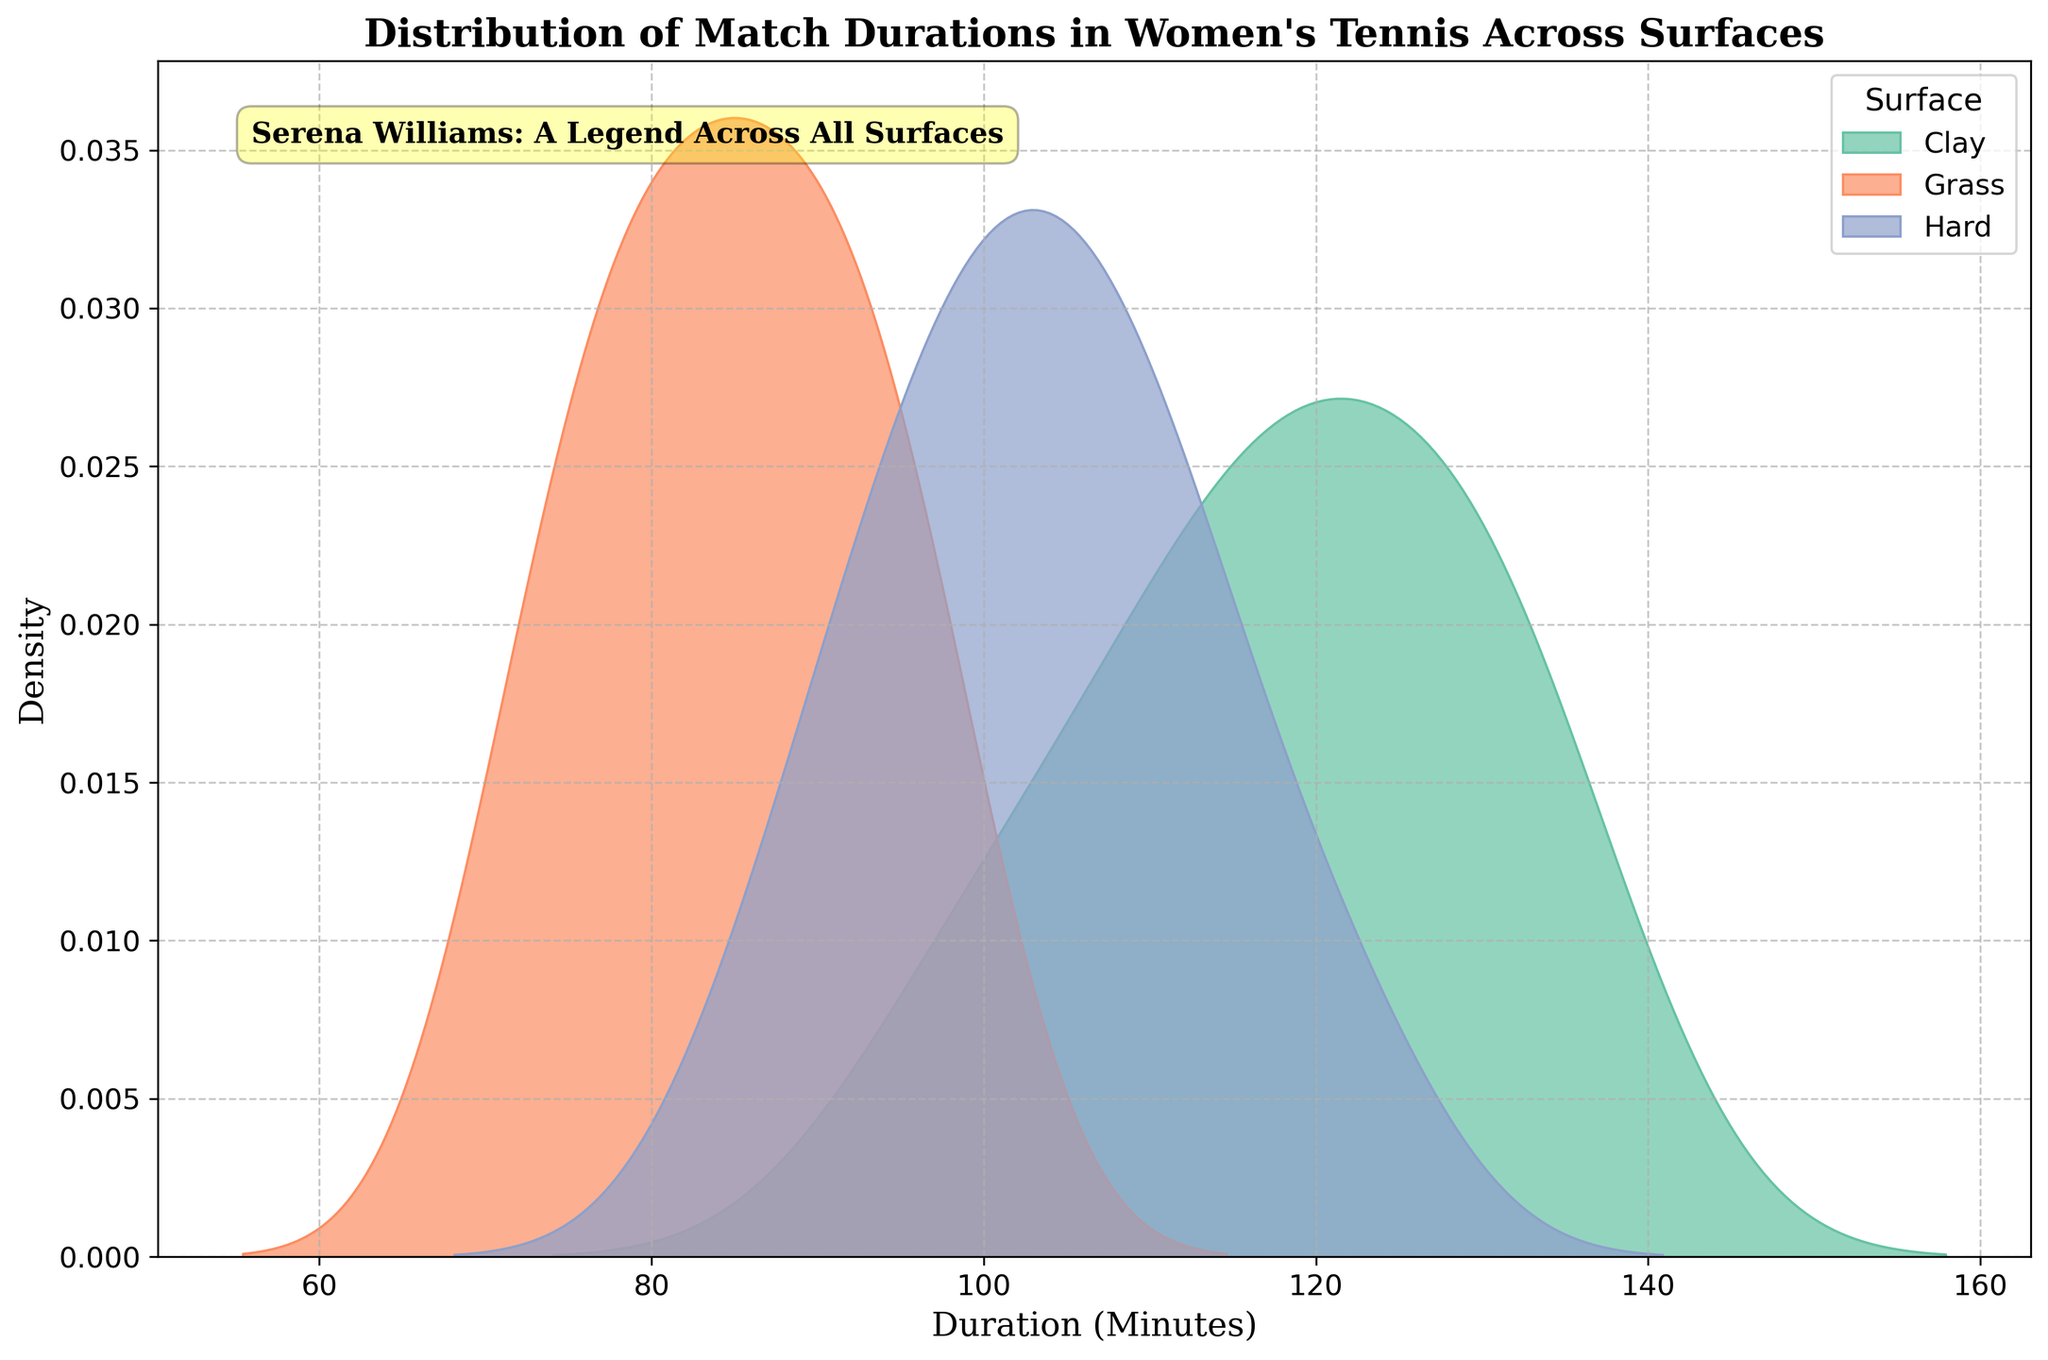What is the title of the figure? The title of the figure is usually placed at the top of the plot. In this case, it reads "Distribution of Match Durations in Women's Tennis Across Surfaces".
Answer: Distribution of Match Durations in Women's Tennis Across Surfaces Which surface has the highest peak in the density plot? To find this, examine the peaks of the different surface curves. The surface with the highest peak in density is the one with the tallest curve.
Answer: Clay What are the axes labels? The axes labels are shown along the x-axis and y-axis of the plot. The x-axis is labeled "Duration (Minutes)" and the y-axis is labeled "Density".
Answer: Duration (Minutes) for x-axis and Density for y-axis Which surface has the shortest match durations based on the density plot? To determine this, look at where the majority of the data points (higher density) is located along the x-axis for each surface. The surface with the data concentrated in the lower end (shorter duration) is the one we are looking for. The Grass surface data is more concentrated on the lower end of the x-axis, indicating shorter match durations.
Answer: Grass How does the density of match durations on hard courts compare to those on clay courts? Compare the density curves for hard and clay courts. Hard courts have a less concentrated distribution than clay courts, meaning matches are spread more across different durations. Clay courts have a sharper peak, indicating more matches are around a specific duration.
Answer: Hard courts are less concentrated while Clay has a sharper peak Which surface shows the greatest variability in match durations? Variability can be understood by looking at how spread out the density curve is. The more spread out, the more variable the durations. The Hard surface curve is more spread out compared to others.
Answer: Hard Is there a specific annotation on the plot? If so, what does it say? Look for any text that is not part of titles or labels. There is an annotation box in the plot that reads "Serena Williams: A Legend Across All Surfaces".
Answer: Serena Williams: A Legend Across All Surfaces 